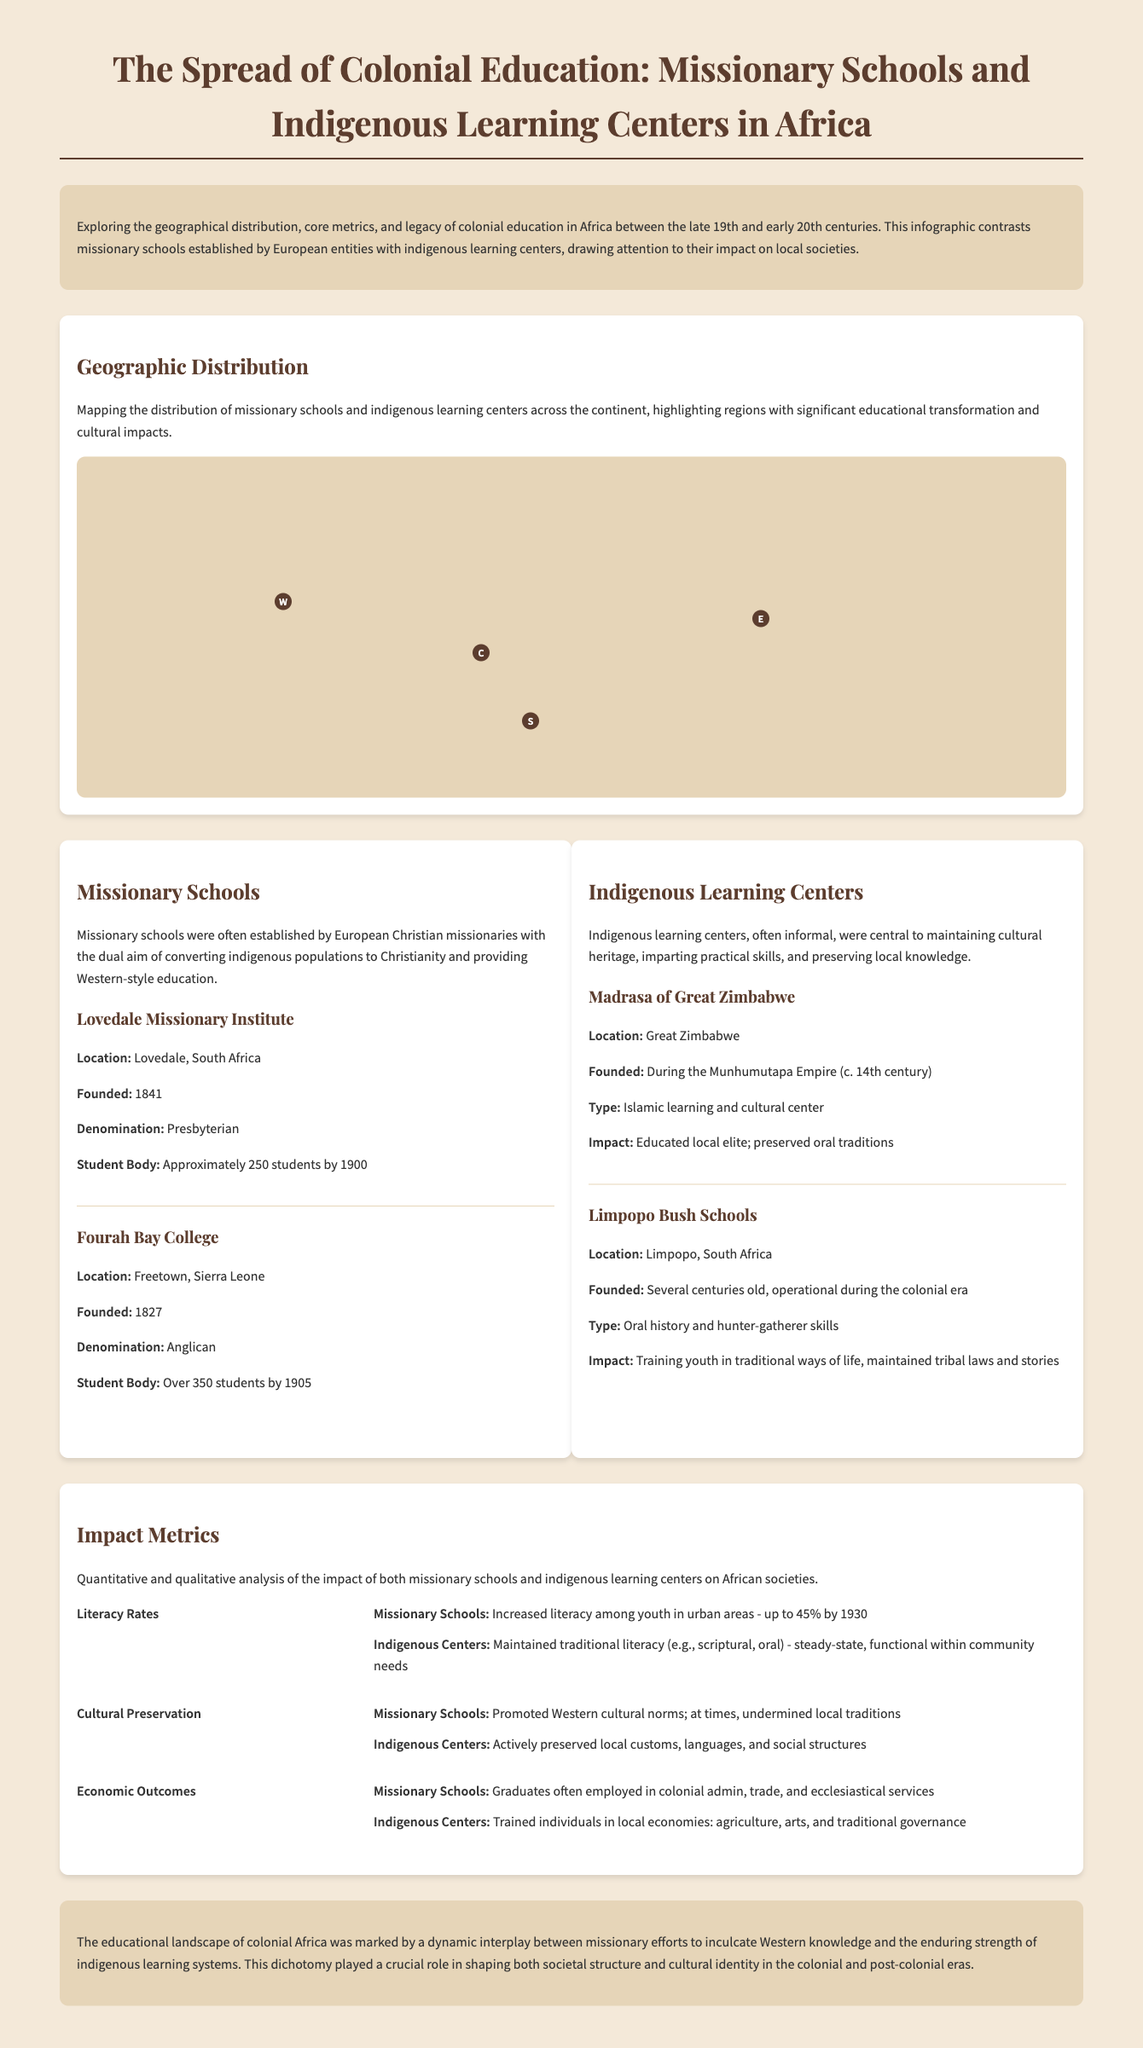What year was the Lovedale Missionary Institute founded? The Lovedale Missionary Institute was established in 1841, as noted in the section about missionary schools.
Answer: 1841 How many missionary schools were there in Southern Africa? The document states that there were 28 missionary schools in Southern Africa, as indicated on the geographic distribution map.
Answer: 28 What is the type of education provided by the Madrasa of Great Zimbabwe? The Madrasa of Great Zimbabwe provided Islamic education and cultural teachings, as described in the section on indigenous learning centers.
Answer: Islamic learning and cultural center By what year did missionary schools achieve up to 45% literacy among youth in urban areas? The document indicates that literacy rates reached up to 45% by 1930 for youth in urban areas educated in missionary schools.
Answer: 1930 What was the primary impact of indigenous centers on local customs? Indigenous centers actively preserved local customs, languages, and social structures, according to the impact metrics section.
Answer: Preserved local customs How many students did Fourah Bay College have by 1905? The number of students at Fourah Bay College was over 350 by 1905, as mentioned in the details of the missionary schools.
Answer: Over 350 Which region had the highest number of indigenous learning centers? The tooltip data for geographic distribution highlights show that West Africa had the highest number of indigenous centers at 12.
Answer: West Africa In what year did the Limpopo Bush Schools operate? The Limpopo Bush Schools were operational during the colonial era, as stated in the description of indigenous learning centers.
Answer: Colonial era 